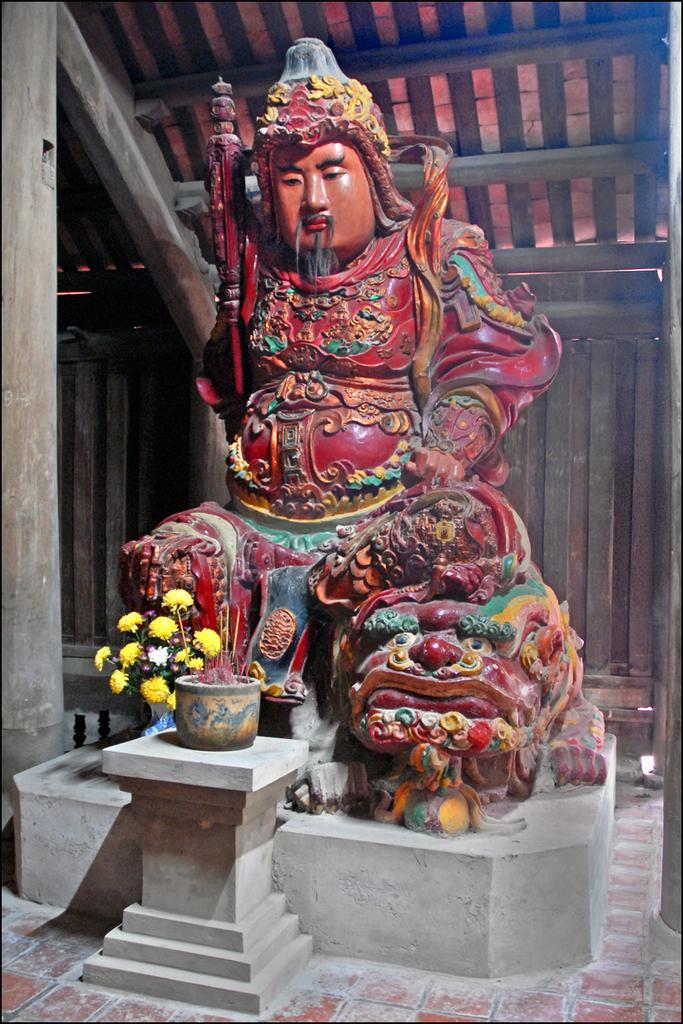Could you give a brief overview of what you see in this image? In this image I can see a statue which is in different color. I can see few yellow color flowers,pot and wooden shed. 